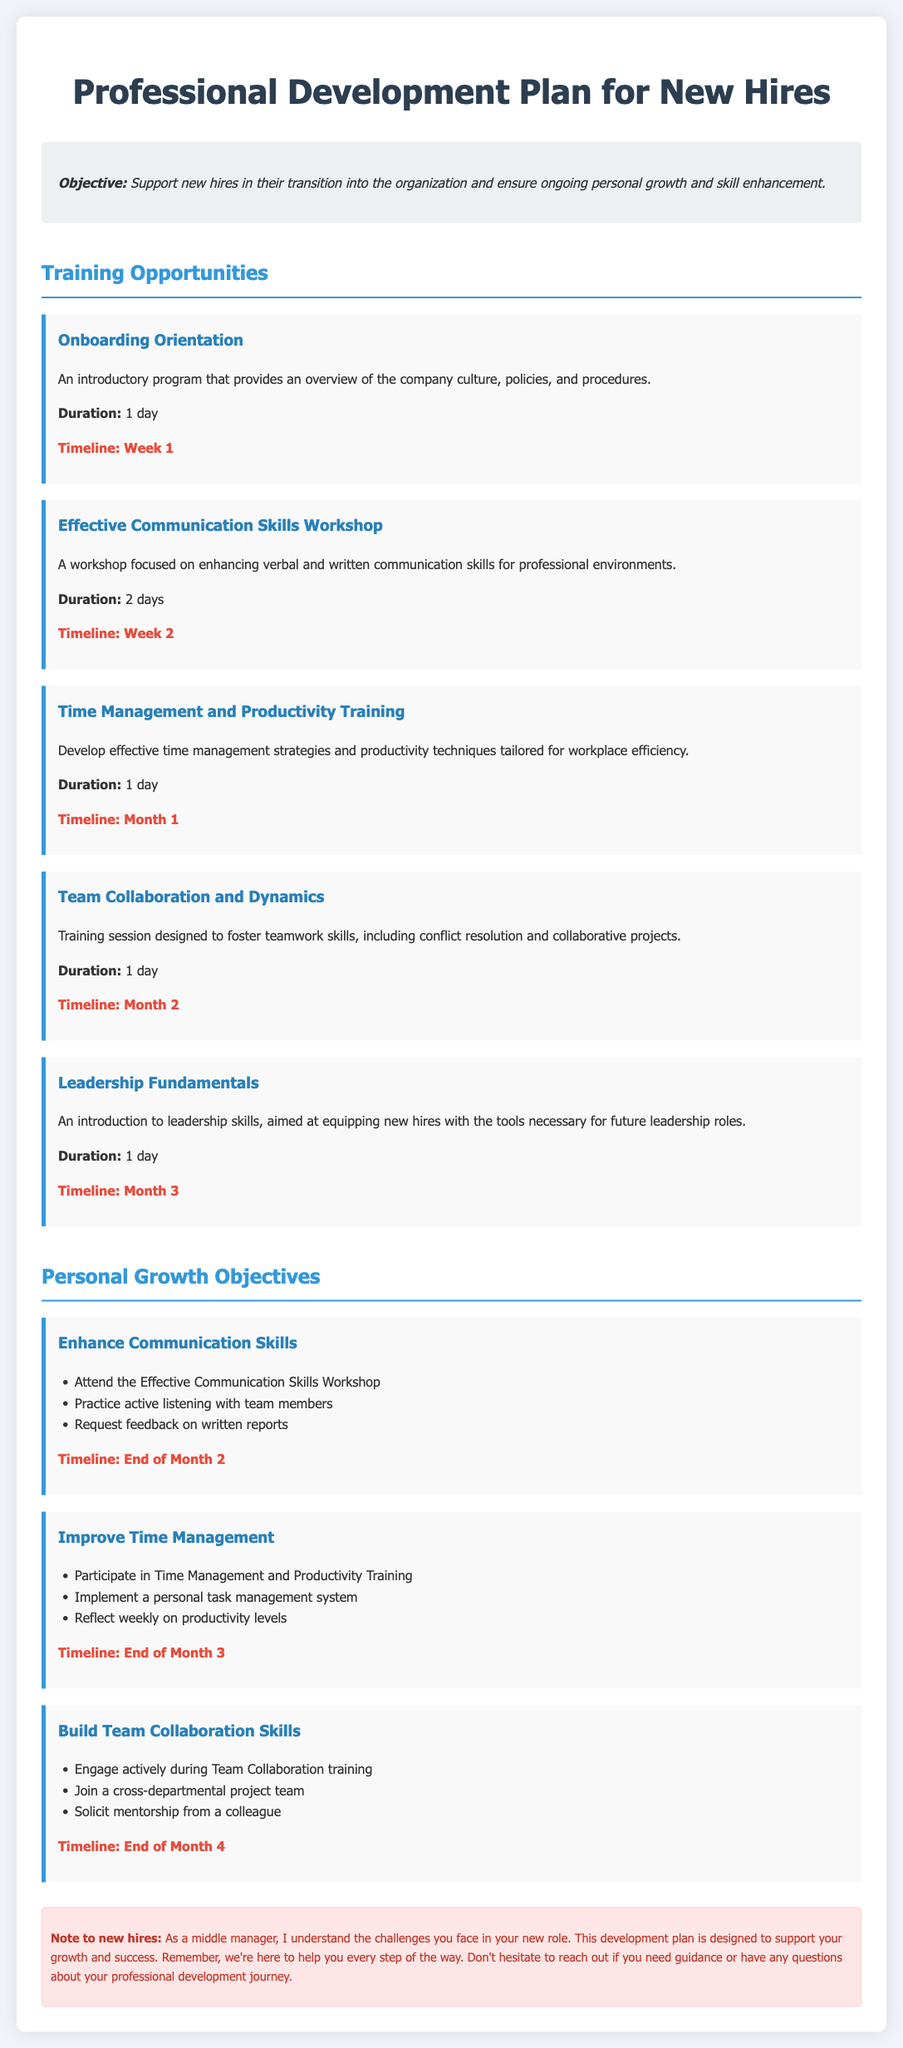What is the objective of the Professional Development Plan? The objective outlines the support for new hires in their transition and ensures ongoing growth and skill enhancement.
Answer: Support new hires in their transition into the organization and ensure ongoing personal growth and skill enhancement How long is the Onboarding Orientation training? This training duration is explicitly provided in the document for the specific training opportunity.
Answer: 1 day When does the Time Management and Productivity Training occur? The timeline for this training is mentioned in the document alongside its duration.
Answer: Month 1 What is one growth objective related to communication skills? The document lists specific goals under personal growth objectives, including actions to improve certain skills.
Answer: Attend the Effective Communication Skills Workshop Which training focuses on leadership skills? This training is identified by its title and is part of the offered training opportunities for new hires.
Answer: Leadership Fundamentals How many days is the Effective Communication Skills Workshop? The duration of this workshop is specifically stated in the document.
Answer: 2 days What is the timeline for enhancing team collaboration skills? The timeline for achieving this growth objective is given in the document, indicating a deadline.
Answer: End of Month 4 What type of document is this? The document is tailored specifically to outline development opportunities and personal objectives for new employees.
Answer: Professional Development Plan What is included in the note for new hires? The note is a supportive message aimed at encouraging new hires as they start their career journey.
Answer: Support your growth and success 